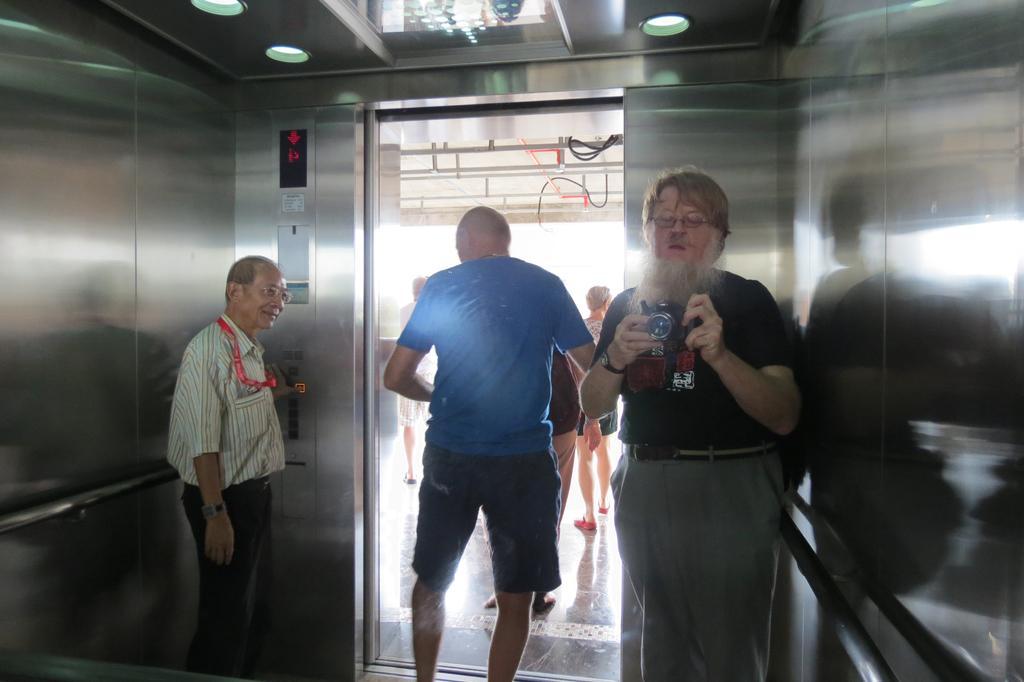How would you summarize this image in a sentence or two? This image consists of a lift. In which there are three persons. On the right, the man is holding a camera and wearing a black T-shirt. In the middle, the man is wearing a blue T-shirt. On the left, the man is standing. In the background, there are two persons. At the top, there is a roof along with lights. 